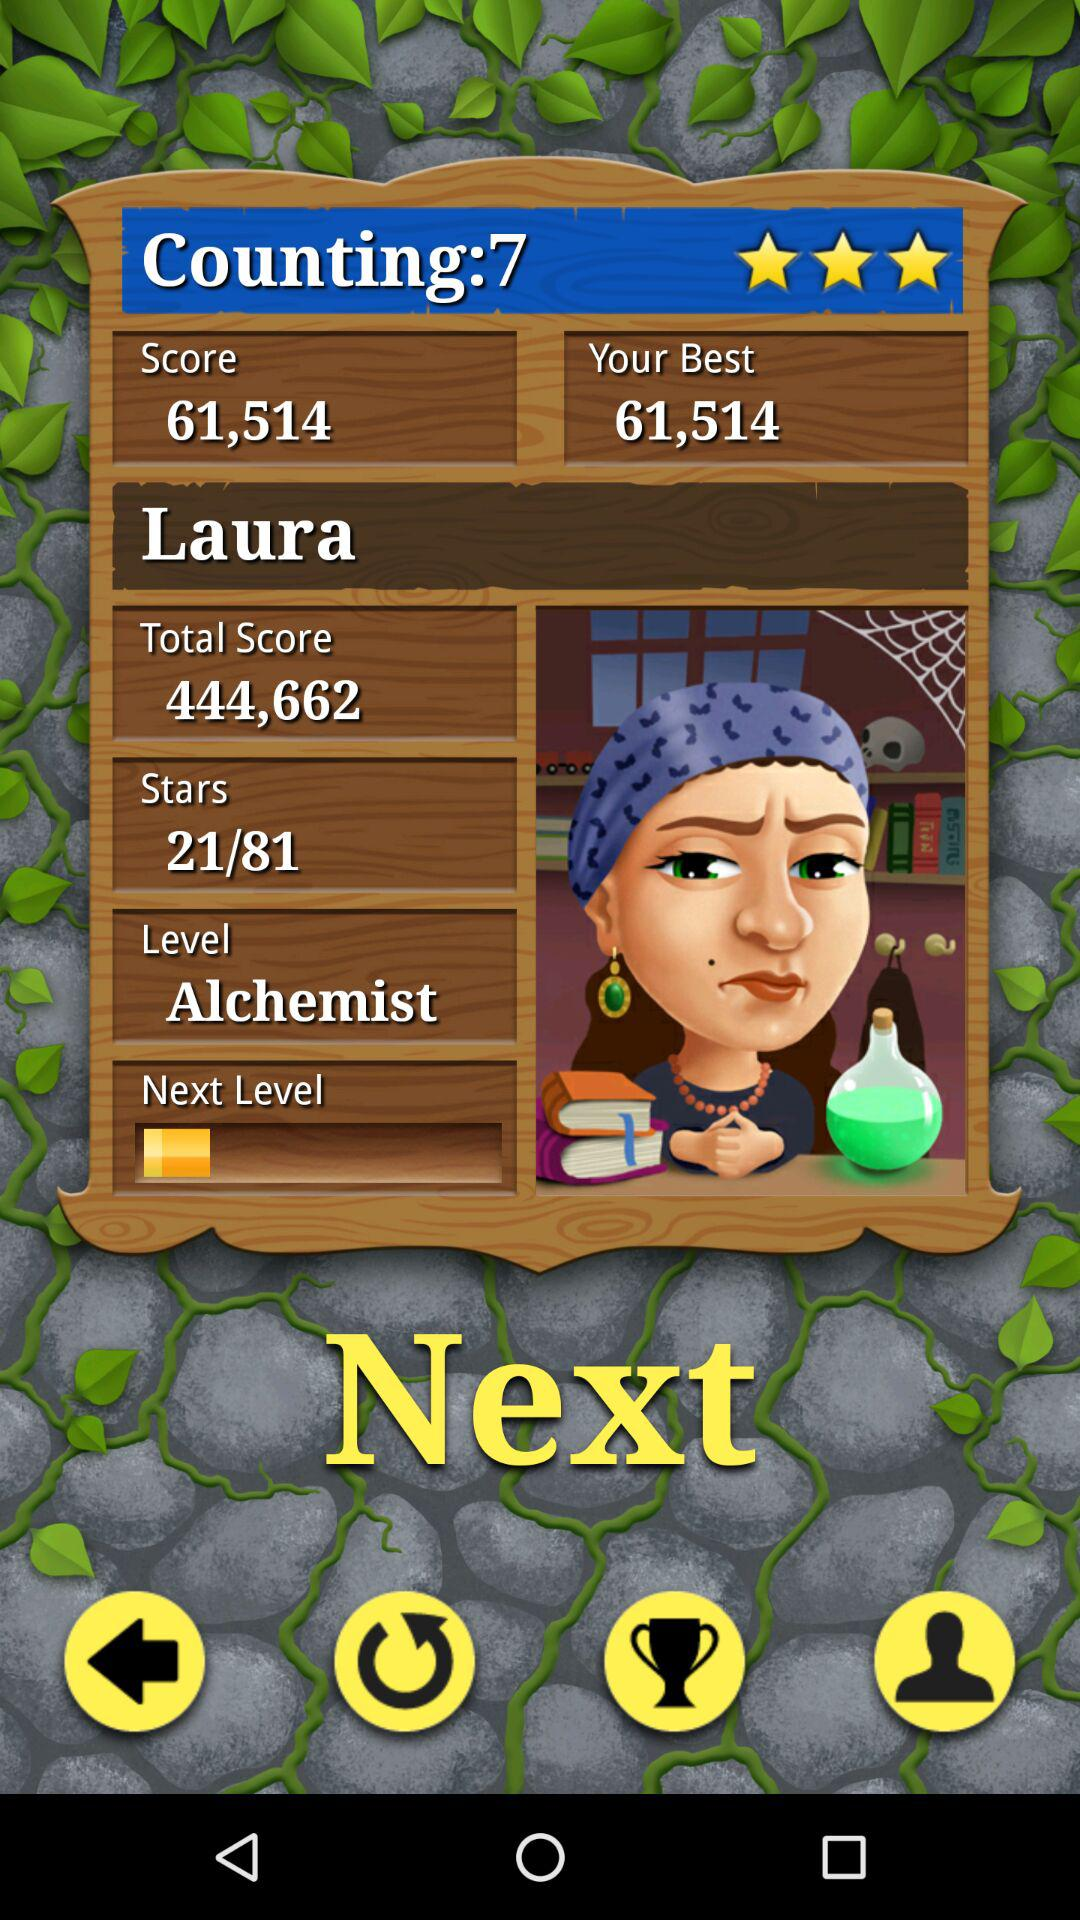What is the level? The level is "Alchemist". 